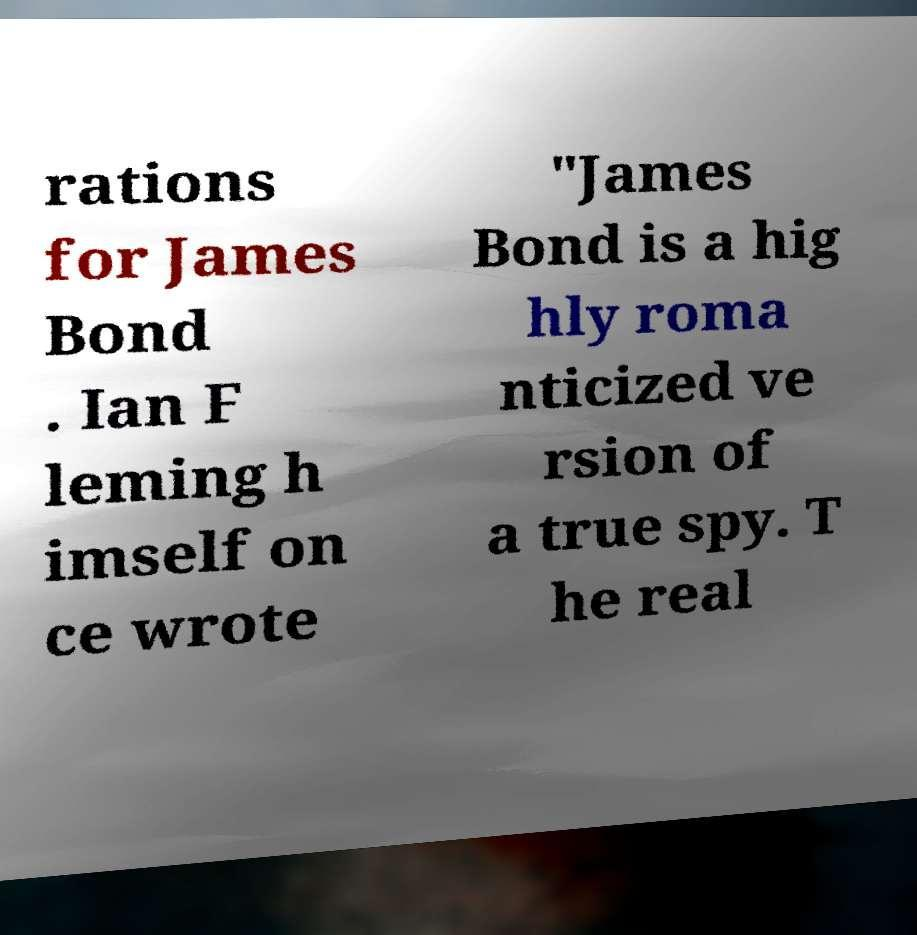There's text embedded in this image that I need extracted. Can you transcribe it verbatim? rations for James Bond . Ian F leming h imself on ce wrote "James Bond is a hig hly roma nticized ve rsion of a true spy. T he real 